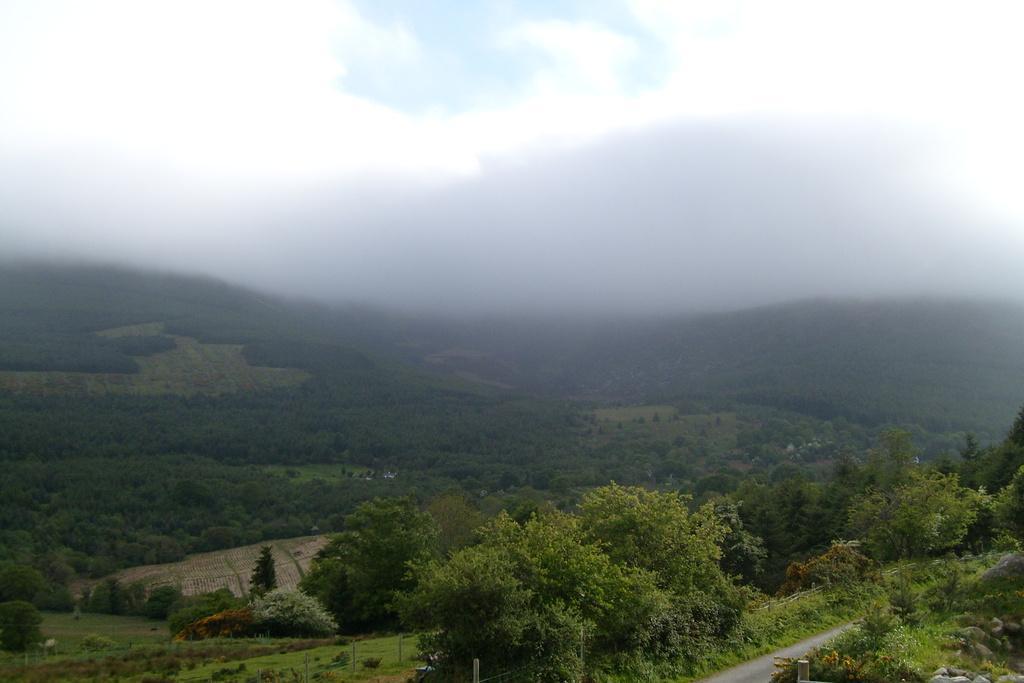How would you summarize this image in a sentence or two? At the bottom of the picture we can see trees, plants, fields, road and poles. In the middle of the picture we can see fields and fog. At the top there is fog. 